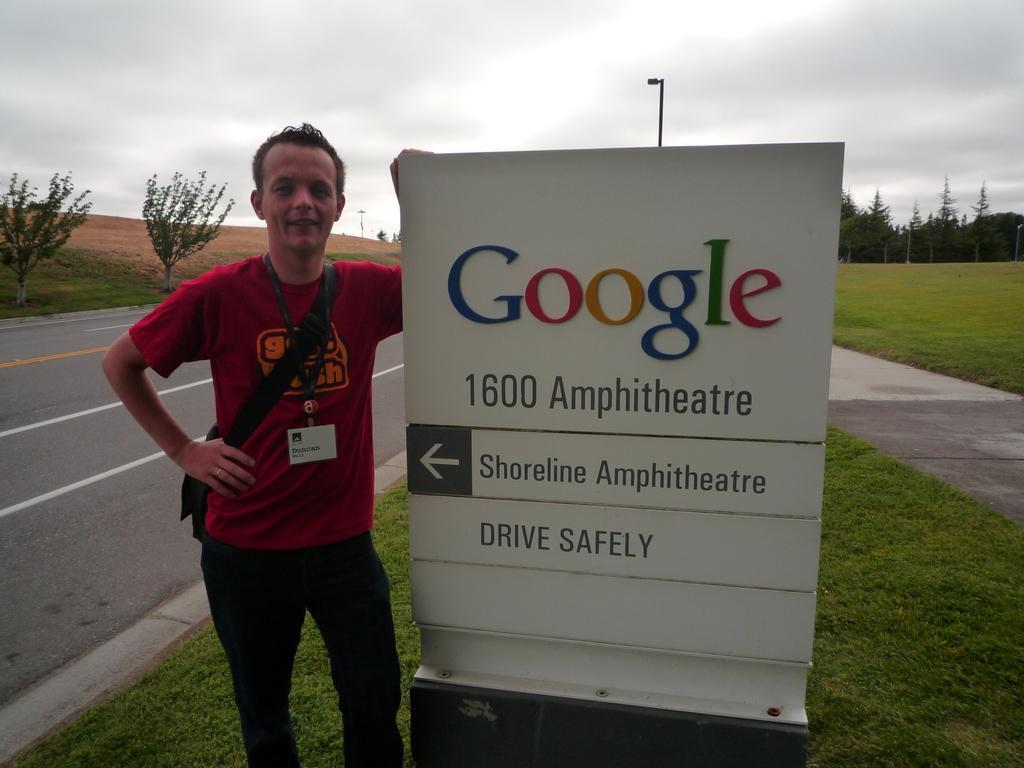Please provide a concise description of this image. this picture there is a Google poster in the center of the image and there is a boy who is standing on the left side of the image, there is a pole behind the poster and there is greenery in the image. 